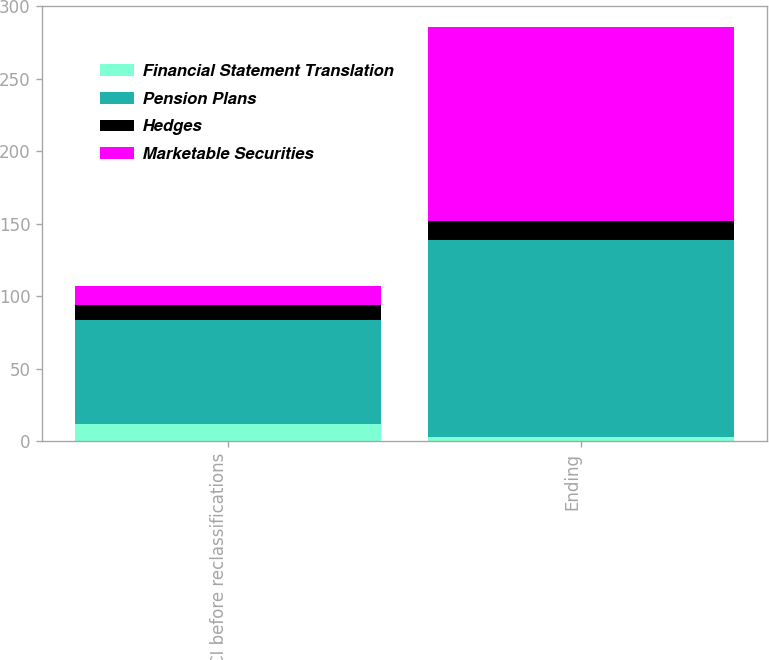<chart> <loc_0><loc_0><loc_500><loc_500><stacked_bar_chart><ecel><fcel>OCI before reclassifications<fcel>Ending<nl><fcel>Financial Statement Translation<fcel>12<fcel>3<nl><fcel>Pension Plans<fcel>72<fcel>136<nl><fcel>Hedges<fcel>10<fcel>13<nl><fcel>Marketable Securities<fcel>13<fcel>134<nl></chart> 